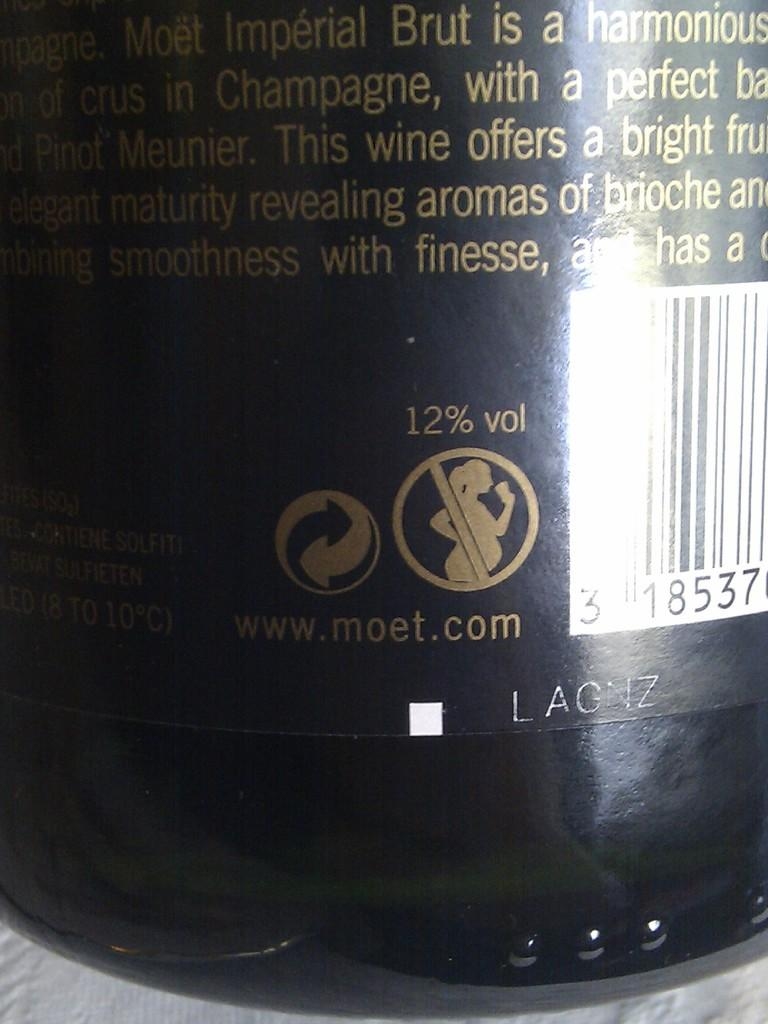<image>
Summarize the visual content of the image. A warning sign on a bottle of Champagne that says pregnant women shouldn't drink wine. 